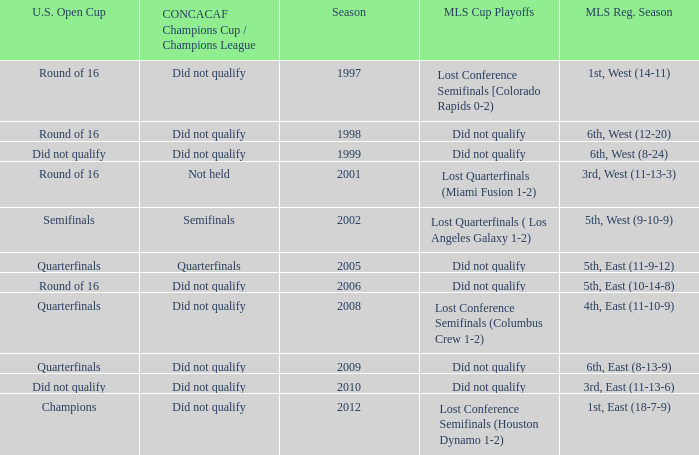What were the placements of the team in regular season when they reached quarterfinals in the U.S. Open Cup but did not qualify for the Concaf Champions Cup? 4th, East (11-10-9), 6th, East (8-13-9). 